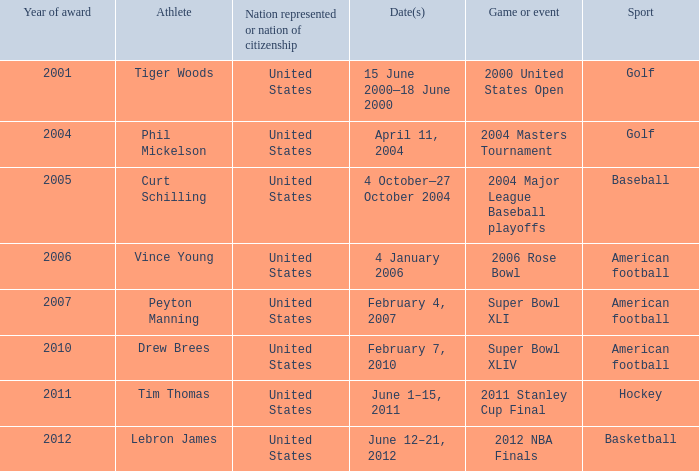In 2011 which sport had the year award? Hockey. 